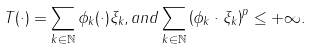<formula> <loc_0><loc_0><loc_500><loc_500>T ( \cdot ) = \sum _ { k \in \mathbb { N } } \phi _ { k } ( \cdot ) \xi _ { k } , a n d \sum _ { k \in \mathbb { N } } \left ( \| \phi _ { k } \| \cdot \| \xi _ { k } \| \right ) ^ { p } \leq + \infty .</formula> 